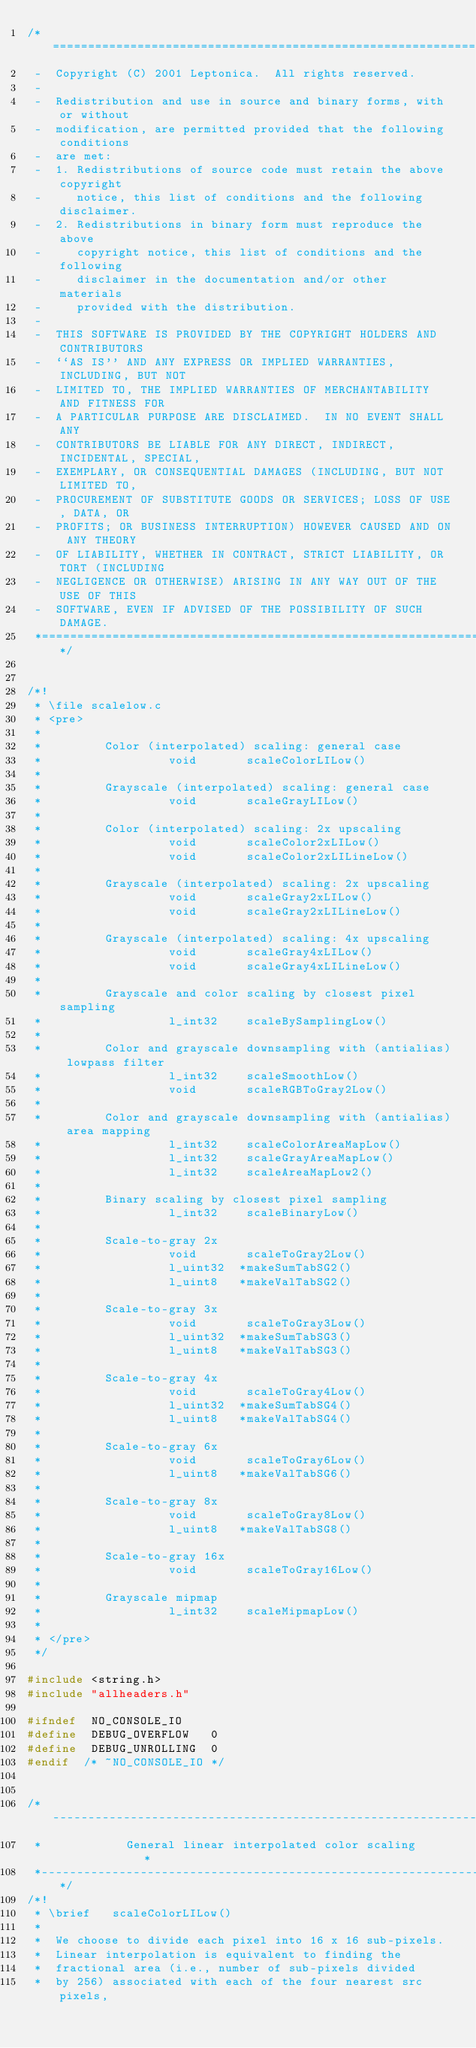<code> <loc_0><loc_0><loc_500><loc_500><_C_>/*====================================================================*
 -  Copyright (C) 2001 Leptonica.  All rights reserved.
 -
 -  Redistribution and use in source and binary forms, with or without
 -  modification, are permitted provided that the following conditions
 -  are met:
 -  1. Redistributions of source code must retain the above copyright
 -     notice, this list of conditions and the following disclaimer.
 -  2. Redistributions in binary form must reproduce the above
 -     copyright notice, this list of conditions and the following
 -     disclaimer in the documentation and/or other materials
 -     provided with the distribution.
 -
 -  THIS SOFTWARE IS PROVIDED BY THE COPYRIGHT HOLDERS AND CONTRIBUTORS
 -  ``AS IS'' AND ANY EXPRESS OR IMPLIED WARRANTIES, INCLUDING, BUT NOT
 -  LIMITED TO, THE IMPLIED WARRANTIES OF MERCHANTABILITY AND FITNESS FOR
 -  A PARTICULAR PURPOSE ARE DISCLAIMED.  IN NO EVENT SHALL ANY
 -  CONTRIBUTORS BE LIABLE FOR ANY DIRECT, INDIRECT, INCIDENTAL, SPECIAL,
 -  EXEMPLARY, OR CONSEQUENTIAL DAMAGES (INCLUDING, BUT NOT LIMITED TO,
 -  PROCUREMENT OF SUBSTITUTE GOODS OR SERVICES; LOSS OF USE, DATA, OR
 -  PROFITS; OR BUSINESS INTERRUPTION) HOWEVER CAUSED AND ON ANY THEORY
 -  OF LIABILITY, WHETHER IN CONTRACT, STRICT LIABILITY, OR TORT (INCLUDING
 -  NEGLIGENCE OR OTHERWISE) ARISING IN ANY WAY OUT OF THE USE OF THIS
 -  SOFTWARE, EVEN IF ADVISED OF THE POSSIBILITY OF SUCH DAMAGE.
 *====================================================================*/


/*!
 * \file scalelow.c
 * <pre>
 *
 *         Color (interpolated) scaling: general case
 *                  void       scaleColorLILow()
 *
 *         Grayscale (interpolated) scaling: general case
 *                  void       scaleGrayLILow()
 *
 *         Color (interpolated) scaling: 2x upscaling
 *                  void       scaleColor2xLILow()
 *                  void       scaleColor2xLILineLow()
 *
 *         Grayscale (interpolated) scaling: 2x upscaling
 *                  void       scaleGray2xLILow()
 *                  void       scaleGray2xLILineLow()
 *
 *         Grayscale (interpolated) scaling: 4x upscaling
 *                  void       scaleGray4xLILow()
 *                  void       scaleGray4xLILineLow()
 *
 *         Grayscale and color scaling by closest pixel sampling
 *                  l_int32    scaleBySamplingLow()
 *
 *         Color and grayscale downsampling with (antialias) lowpass filter
 *                  l_int32    scaleSmoothLow()
 *                  void       scaleRGBToGray2Low()
 *
 *         Color and grayscale downsampling with (antialias) area mapping
 *                  l_int32    scaleColorAreaMapLow()
 *                  l_int32    scaleGrayAreaMapLow()
 *                  l_int32    scaleAreaMapLow2()
 *
 *         Binary scaling by closest pixel sampling
 *                  l_int32    scaleBinaryLow()
 *
 *         Scale-to-gray 2x
 *                  void       scaleToGray2Low()
 *                  l_uint32  *makeSumTabSG2()
 *                  l_uint8   *makeValTabSG2()
 *
 *         Scale-to-gray 3x
 *                  void       scaleToGray3Low()
 *                  l_uint32  *makeSumTabSG3()
 *                  l_uint8   *makeValTabSG3()
 *
 *         Scale-to-gray 4x
 *                  void       scaleToGray4Low()
 *                  l_uint32  *makeSumTabSG4()
 *                  l_uint8   *makeValTabSG4()
 *
 *         Scale-to-gray 6x
 *                  void       scaleToGray6Low()
 *                  l_uint8   *makeValTabSG6()
 *
 *         Scale-to-gray 8x
 *                  void       scaleToGray8Low()
 *                  l_uint8   *makeValTabSG8()
 *
 *         Scale-to-gray 16x
 *                  void       scaleToGray16Low()
 *
 *         Grayscale mipmap
 *                  l_int32    scaleMipmapLow()
 *
 * </pre>
 */

#include <string.h>
#include "allheaders.h"

#ifndef  NO_CONSOLE_IO
#define  DEBUG_OVERFLOW   0
#define  DEBUG_UNROLLING  0
#endif  /* ~NO_CONSOLE_IO */


/*------------------------------------------------------------------*
 *            General linear interpolated color scaling             *
 *------------------------------------------------------------------*/
/*!
 * \brief   scaleColorLILow()
 *
 *  We choose to divide each pixel into 16 x 16 sub-pixels.
 *  Linear interpolation is equivalent to finding the
 *  fractional area (i.e., number of sub-pixels divided
 *  by 256) associated with each of the four nearest src pixels,</code> 